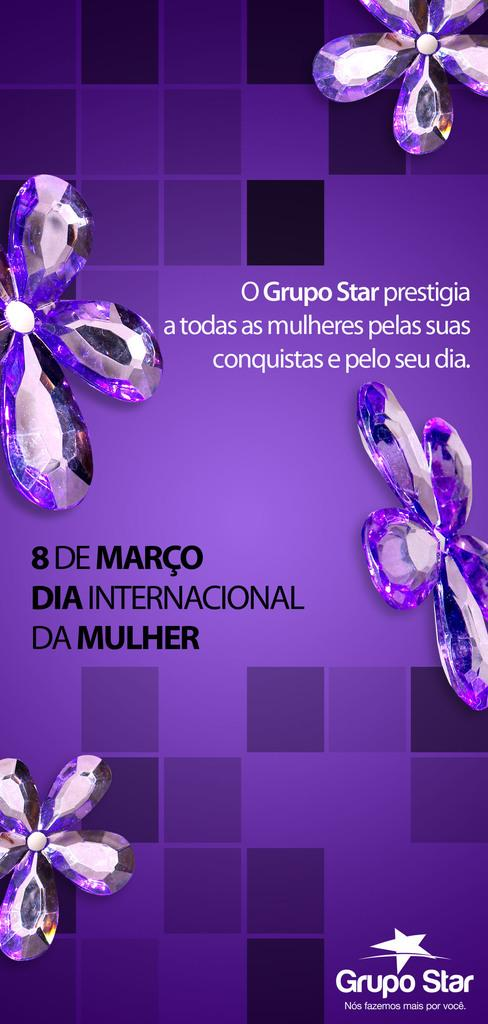What type of visual is the image? The image is a poster. What is depicted on the poster? There are stones depicted on the poster. Are there any words on the poster? Yes, there is text on the poster. What color is the poster? The poster is in violet color. How many balls are bouncing around the stones in the poster? There are no balls present in the poster; it features stones and text. What type of birds can be seen flying over the stones in the poster? There are no birds depicted in the poster; it only features stones and text. 